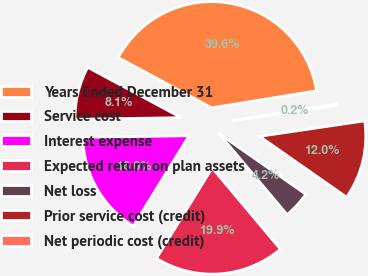<chart> <loc_0><loc_0><loc_500><loc_500><pie_chart><fcel>Years Ended December 31<fcel>Service cost<fcel>Interest expense<fcel>Expected return on plan assets<fcel>Net loss<fcel>Prior service cost (credit)<fcel>Net periodic cost (credit)<nl><fcel>39.58%<fcel>8.1%<fcel>15.97%<fcel>19.91%<fcel>4.17%<fcel>12.04%<fcel>0.24%<nl></chart> 